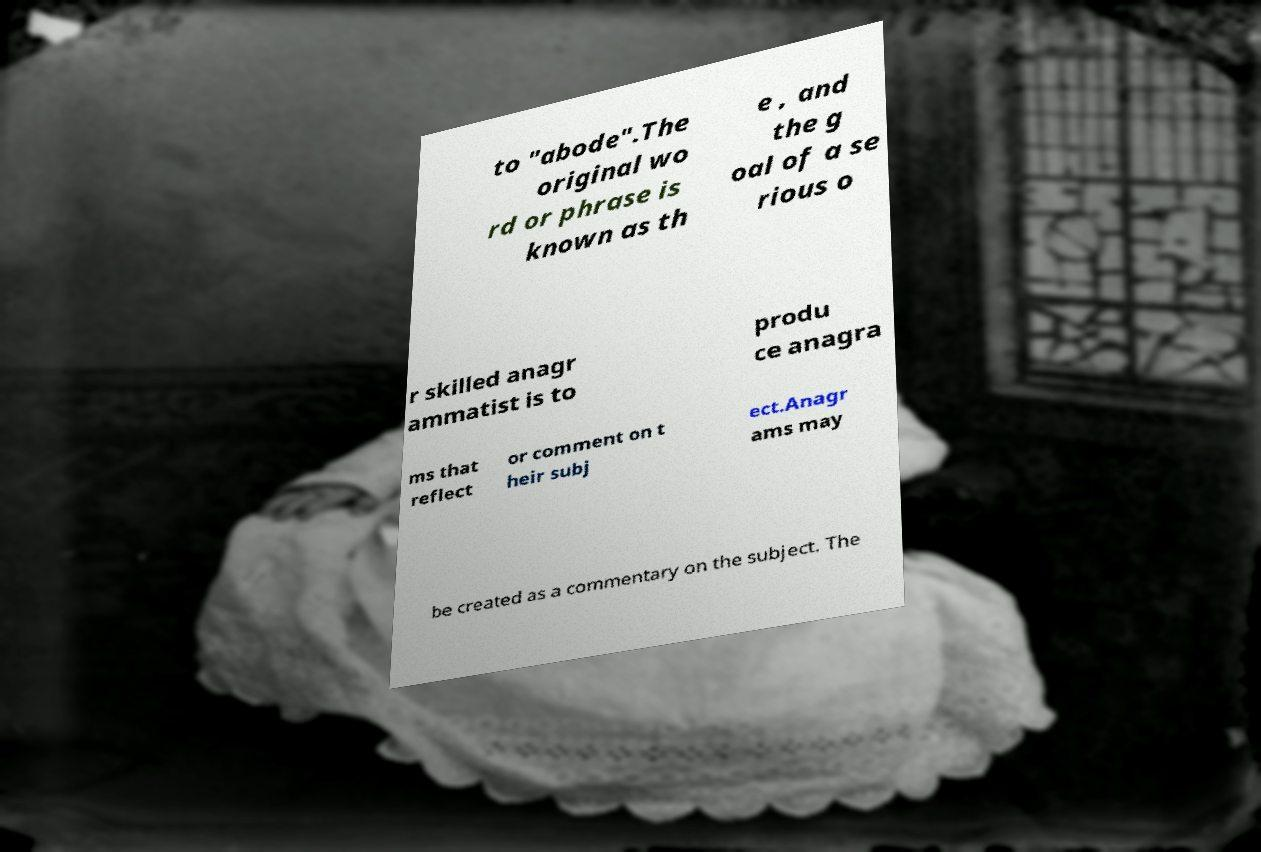There's text embedded in this image that I need extracted. Can you transcribe it verbatim? to "abode".The original wo rd or phrase is known as th e , and the g oal of a se rious o r skilled anagr ammatist is to produ ce anagra ms that reflect or comment on t heir subj ect.Anagr ams may be created as a commentary on the subject. The 